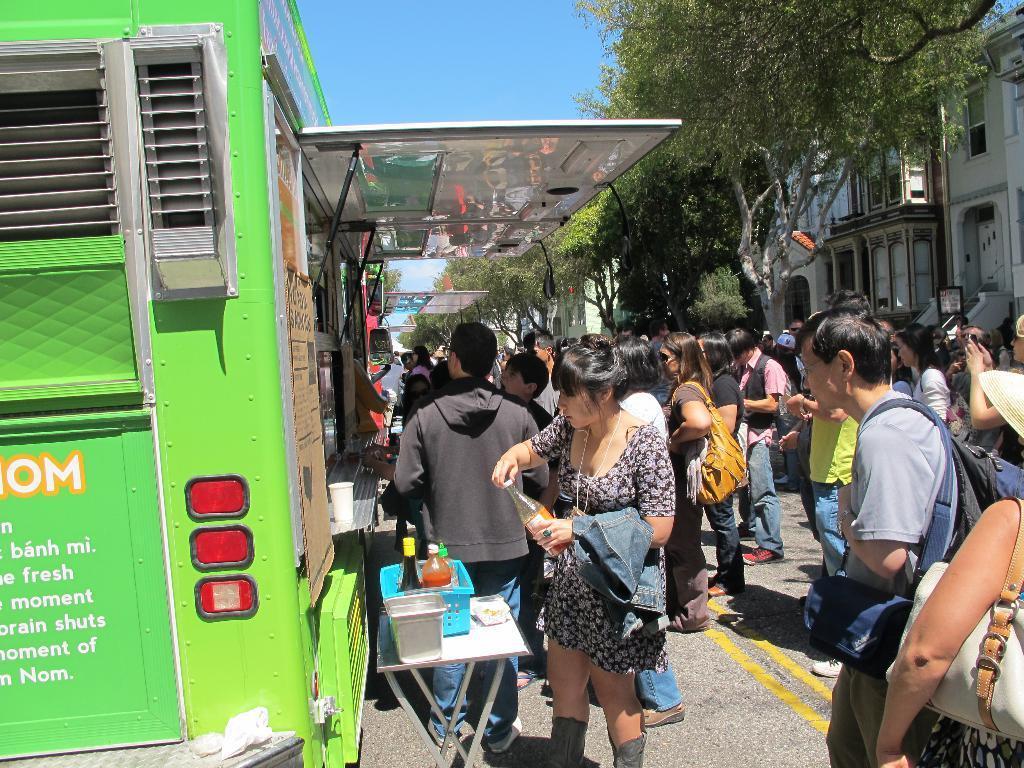In one or two sentences, can you explain what this image depicts? Here we can see that a group of people are standing on the road, and here is the tree, and here is the building, and at above here is the sky. 